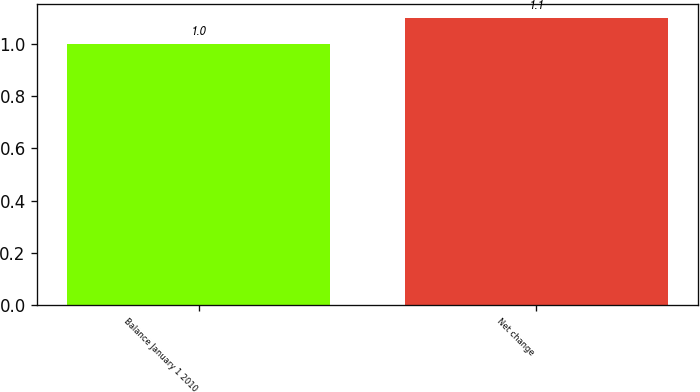Convert chart to OTSL. <chart><loc_0><loc_0><loc_500><loc_500><bar_chart><fcel>Balance January 1 2010<fcel>Net change<nl><fcel>1<fcel>1.1<nl></chart> 